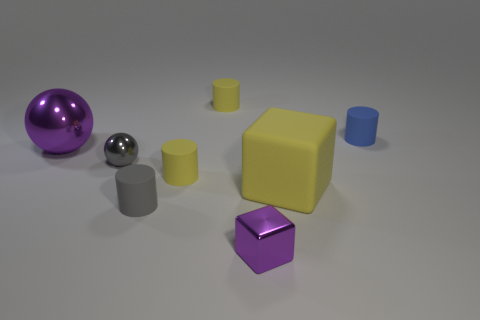Subtract all gray cylinders. How many cylinders are left? 3 Subtract all small gray matte cylinders. How many cylinders are left? 3 Subtract all red cylinders. Subtract all gray cubes. How many cylinders are left? 4 Add 2 big yellow cubes. How many objects exist? 10 Subtract all cubes. How many objects are left? 6 Add 8 large red spheres. How many large red spheres exist? 8 Subtract 0 brown spheres. How many objects are left? 8 Subtract all large purple rubber things. Subtract all gray metallic balls. How many objects are left? 7 Add 6 small blue rubber things. How many small blue rubber things are left? 7 